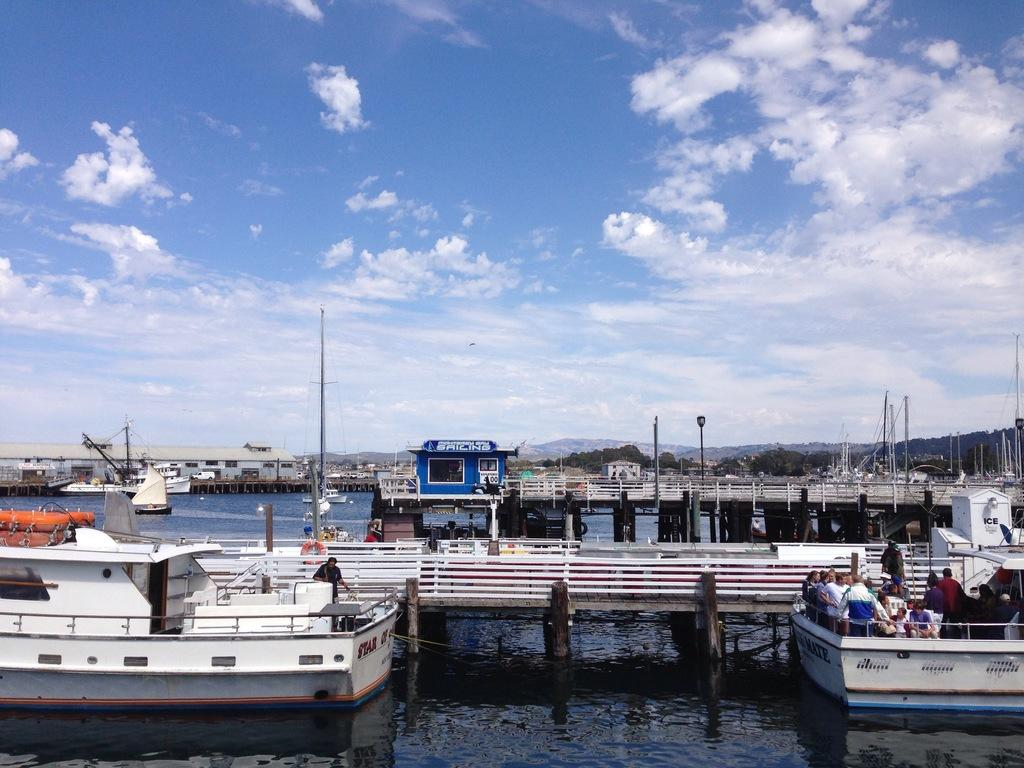What is the main setting of the image? There is a harbor in the image. What type of boats can be seen in the harbor? There are white boats in the harbor. What part of the natural environment is visible in the image? The sky is visible in the image. What can be observed in the sky? Clouds are present in the sky. What type of game is being played on the boats in the image? There is no indication of a game being played on the boats in the image. 